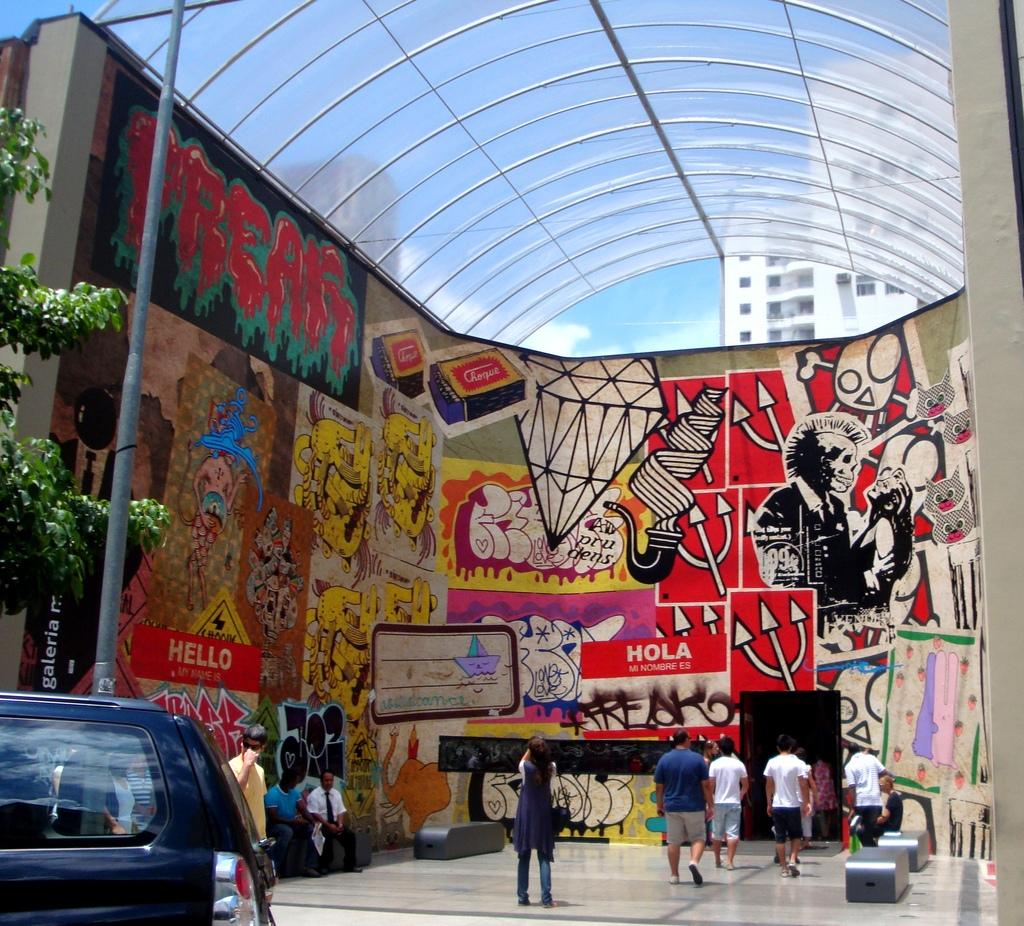<image>
Provide a brief description of the given image. People enter a large building adorned with loud images and the words hello and hola. 